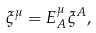Convert formula to latex. <formula><loc_0><loc_0><loc_500><loc_500>\xi ^ { \mu } = E _ { A } ^ { \mu } \xi ^ { A } ,</formula> 